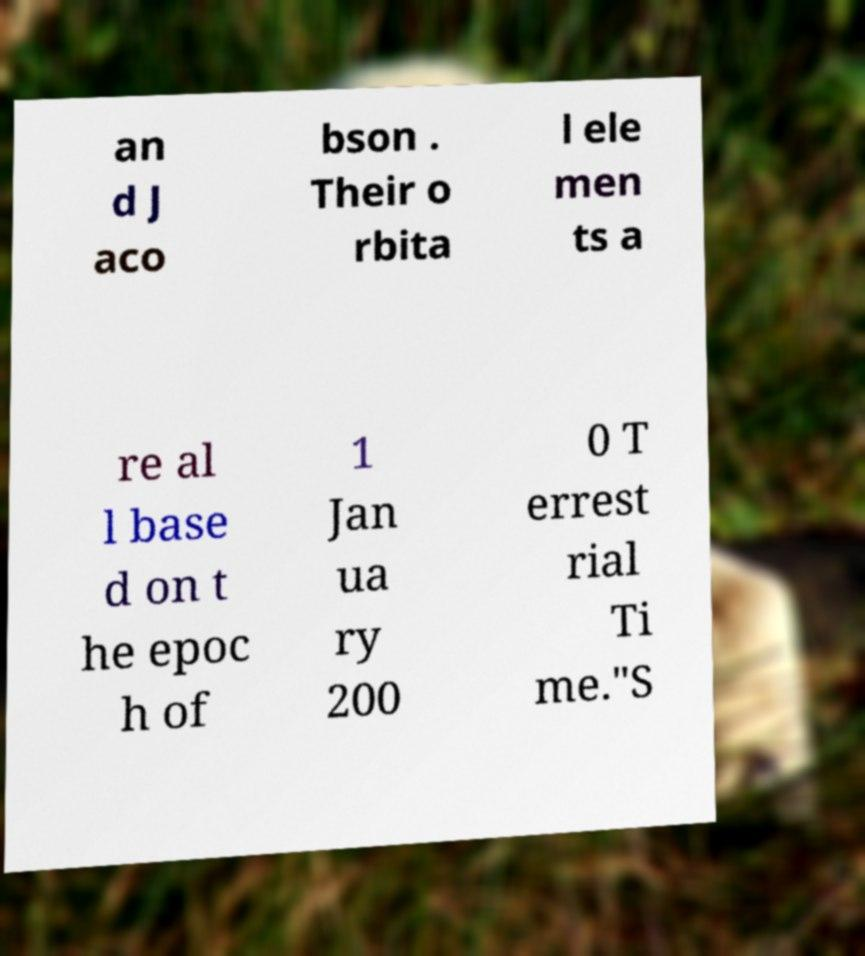I need the written content from this picture converted into text. Can you do that? an d J aco bson . Their o rbita l ele men ts a re al l base d on t he epoc h of 1 Jan ua ry 200 0 T errest rial Ti me."S 